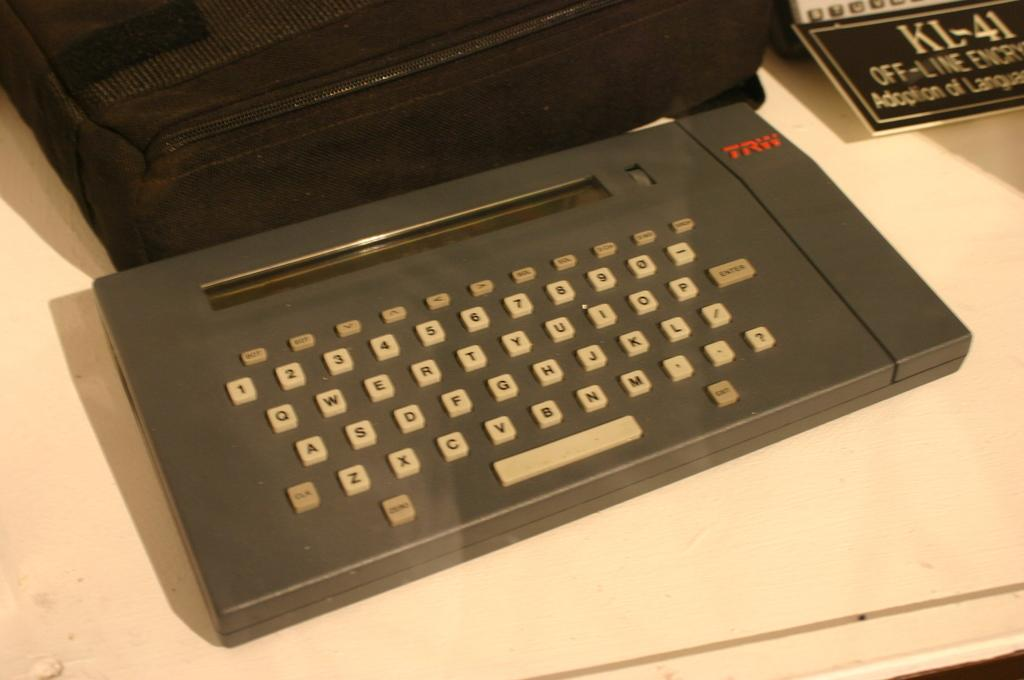<image>
Relay a brief, clear account of the picture shown. An old machine with a keyboard was made by TRW and now sits on a white table. 